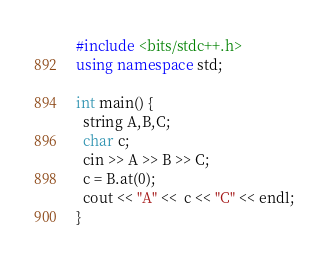<code> <loc_0><loc_0><loc_500><loc_500><_C++_>#include <bits/stdc++.h>
using namespace std;
 
int main() {
  string A,B,C;
  char c;
  cin >> A >> B >> C;
  c = B.at(0);
  cout << "A" <<  c << "C" << endl;
}</code> 